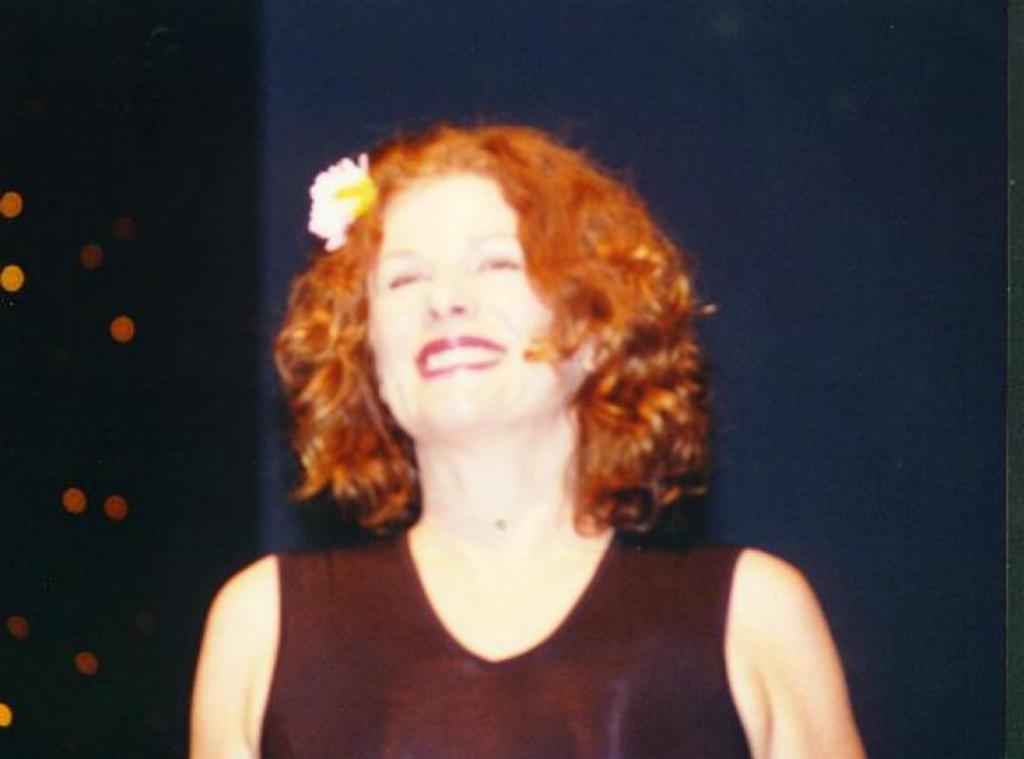What is the main subject of the image? There is a person in the image. What is the person doing in the image? The person is smiling. Can you describe the background of the image? The background of the image is blurred. What shape is the pancake in the image? There is no pancake present in the image. What type of land can be seen in the background of the image? The background of the image is blurred, so it is not possible to determine the type of land in the image. 